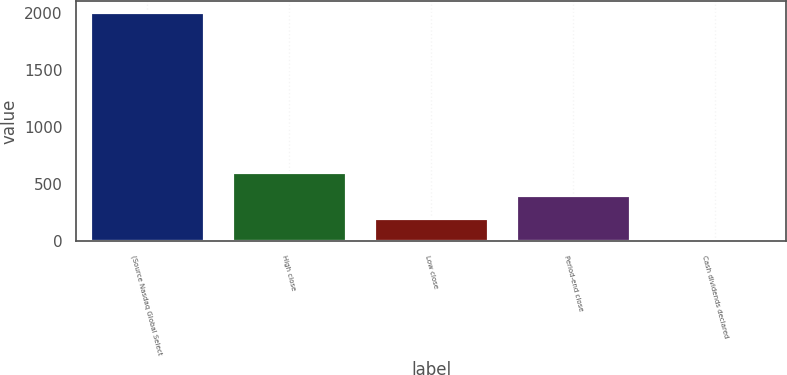Convert chart. <chart><loc_0><loc_0><loc_500><loc_500><bar_chart><fcel>(Source Nasdaq Global Select<fcel>High close<fcel>Low close<fcel>Period-end close<fcel>Cash dividends declared<nl><fcel>2008<fcel>602.67<fcel>201.15<fcel>401.91<fcel>0.39<nl></chart> 